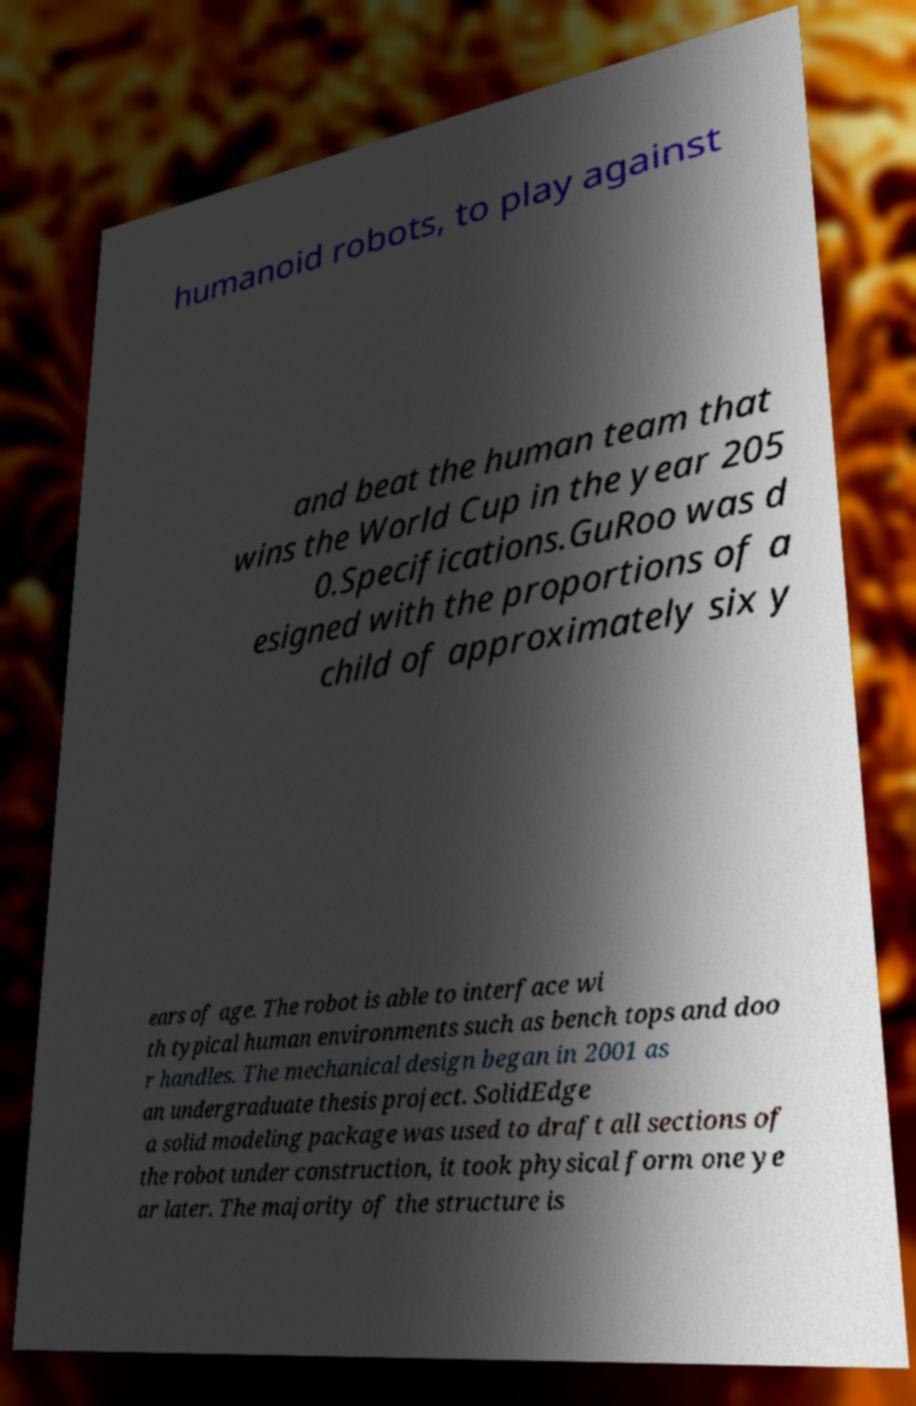Could you extract and type out the text from this image? humanoid robots, to play against and beat the human team that wins the World Cup in the year 205 0.Specifications.GuRoo was d esigned with the proportions of a child of approximately six y ears of age. The robot is able to interface wi th typical human environments such as bench tops and doo r handles. The mechanical design began in 2001 as an undergraduate thesis project. SolidEdge a solid modeling package was used to draft all sections of the robot under construction, it took physical form one ye ar later. The majority of the structure is 